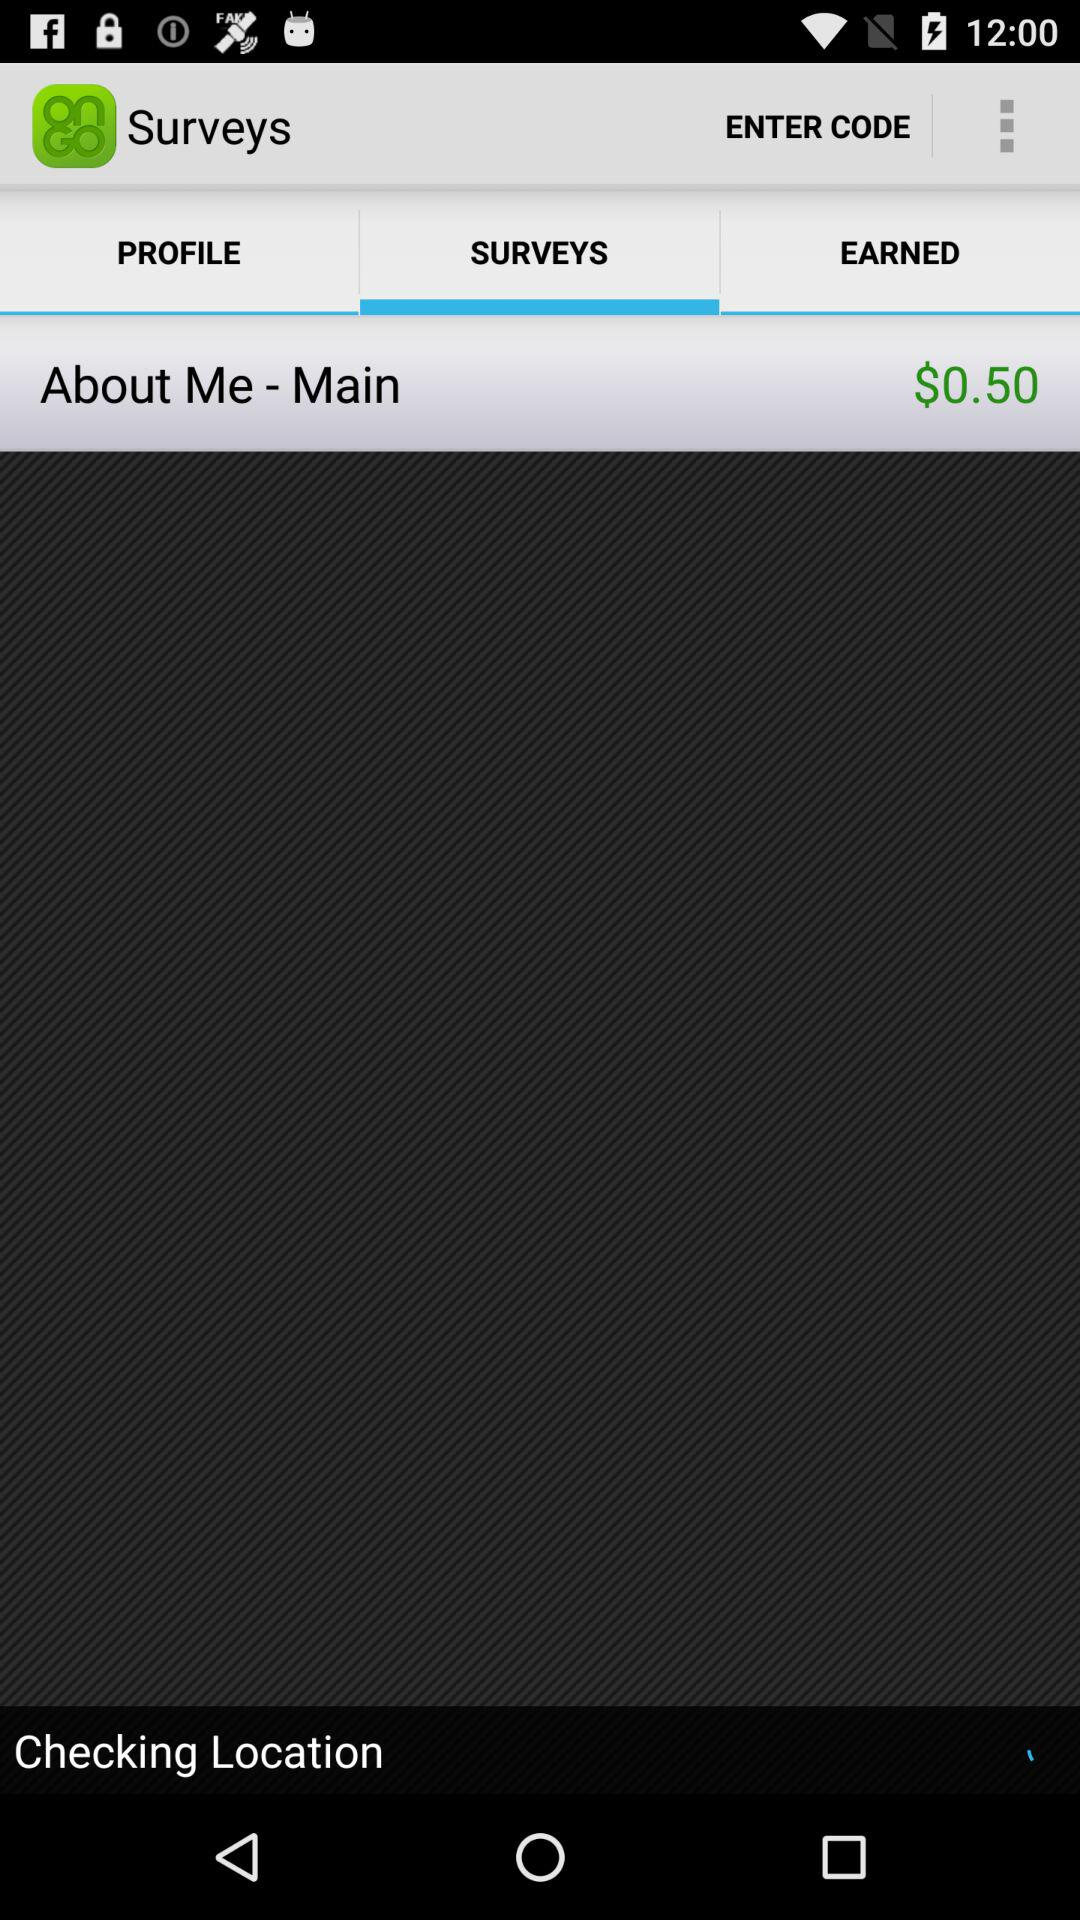How much of the amount is shown? The shown amount is $0.50. 